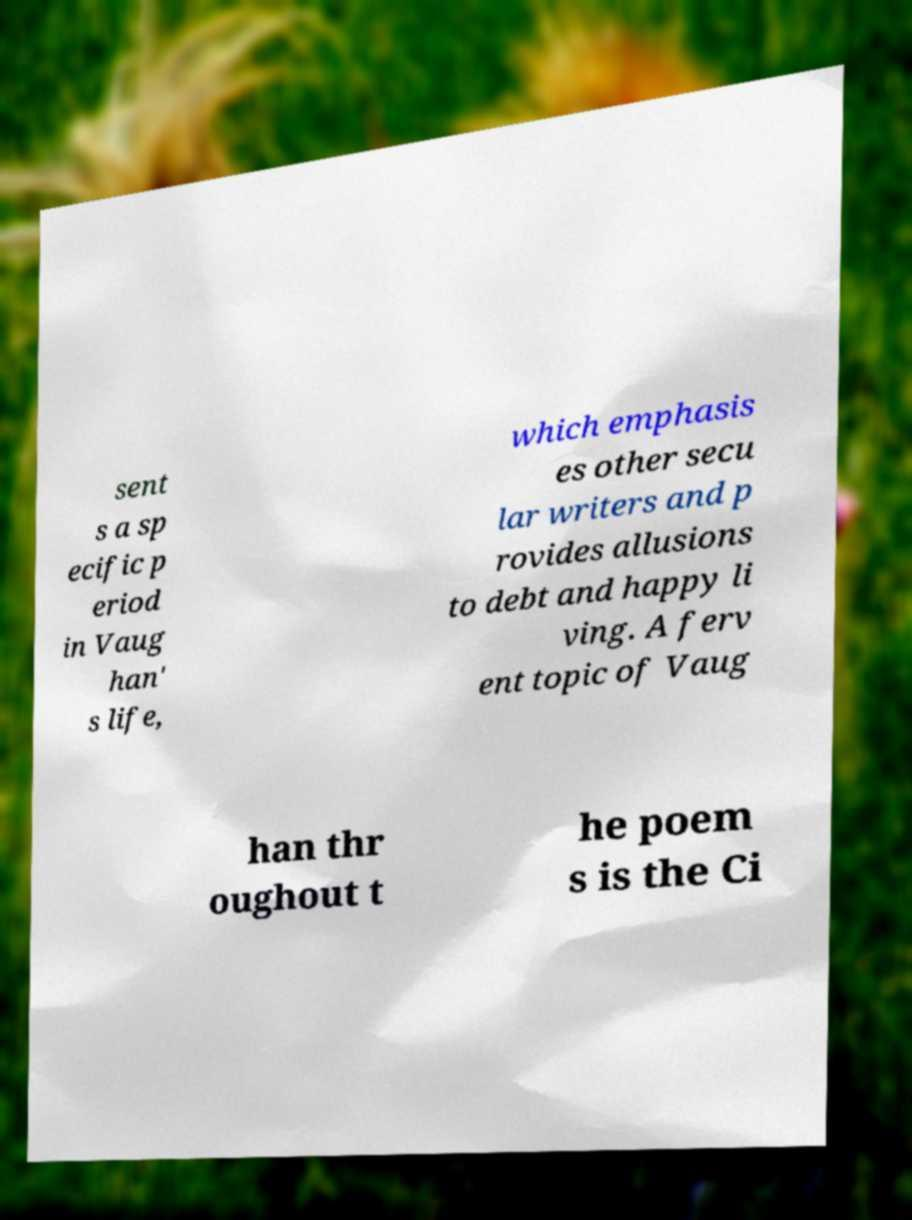Please read and relay the text visible in this image. What does it say? sent s a sp ecific p eriod in Vaug han' s life, which emphasis es other secu lar writers and p rovides allusions to debt and happy li ving. A ferv ent topic of Vaug han thr oughout t he poem s is the Ci 